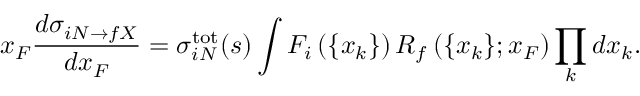<formula> <loc_0><loc_0><loc_500><loc_500>x _ { F } \frac { d \sigma _ { i N \rightarrow f X } } { d x _ { F } } = \sigma _ { i N } ^ { t o t } ( s ) \int F _ { i } \left ( \{ x _ { k } \} \right ) R _ { f } \left ( \{ x _ { k } \} ; x _ { F } \right ) \prod _ { k } d x _ { k } .</formula> 